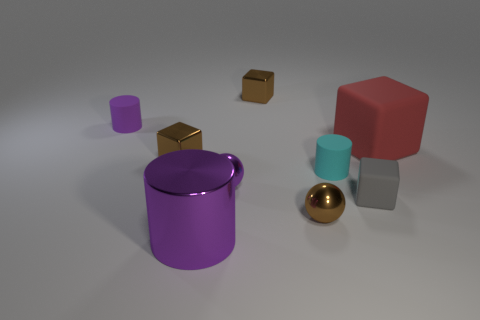Subtract all big cubes. How many cubes are left? 3 Add 1 tiny cyan shiny objects. How many objects exist? 10 Subtract all cubes. How many objects are left? 5 Subtract all blue cylinders. How many purple spheres are left? 1 Subtract all large green cubes. Subtract all big red things. How many objects are left? 8 Add 9 red blocks. How many red blocks are left? 10 Add 8 small brown cubes. How many small brown cubes exist? 10 Subtract all gray cubes. How many cubes are left? 3 Subtract 1 gray cubes. How many objects are left? 8 Subtract 2 spheres. How many spheres are left? 0 